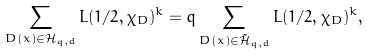<formula> <loc_0><loc_0><loc_500><loc_500>\sum _ { D ( x ) \in \mathcal { H } _ { q , d } } L ( 1 / 2 , \chi _ { D } ) ^ { k } = q \sum _ { D ( x ) \in \tilde { \mathcal { H } } _ { q , d } } L ( 1 / 2 , \chi _ { D } ) ^ { k } ,</formula> 